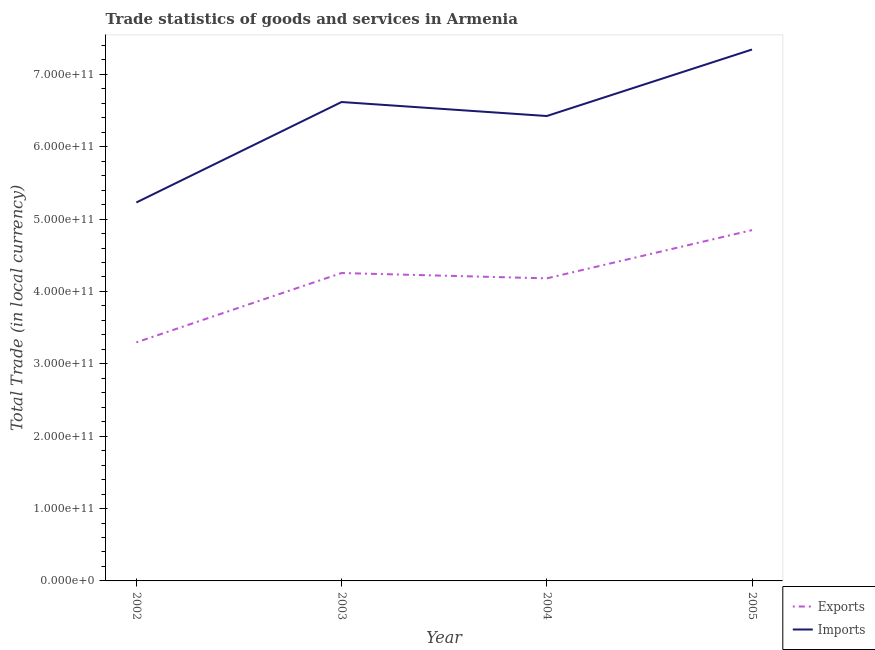Is the number of lines equal to the number of legend labels?
Your answer should be very brief. Yes. What is the export of goods and services in 2003?
Your answer should be very brief. 4.25e+11. Across all years, what is the maximum imports of goods and services?
Give a very brief answer. 7.34e+11. Across all years, what is the minimum export of goods and services?
Offer a very short reply. 3.30e+11. In which year was the imports of goods and services maximum?
Give a very brief answer. 2005. What is the total export of goods and services in the graph?
Make the answer very short. 1.66e+12. What is the difference between the imports of goods and services in 2003 and that in 2005?
Offer a very short reply. -7.26e+1. What is the difference between the export of goods and services in 2005 and the imports of goods and services in 2004?
Ensure brevity in your answer.  -1.58e+11. What is the average imports of goods and services per year?
Offer a very short reply. 6.40e+11. In the year 2003, what is the difference between the imports of goods and services and export of goods and services?
Offer a terse response. 2.36e+11. What is the ratio of the export of goods and services in 2002 to that in 2004?
Make the answer very short. 0.79. Is the export of goods and services in 2003 less than that in 2005?
Your answer should be compact. Yes. What is the difference between the highest and the second highest export of goods and services?
Offer a very short reply. 5.93e+1. What is the difference between the highest and the lowest imports of goods and services?
Ensure brevity in your answer.  2.11e+11. Is the imports of goods and services strictly less than the export of goods and services over the years?
Ensure brevity in your answer.  No. How many years are there in the graph?
Provide a short and direct response. 4. What is the difference between two consecutive major ticks on the Y-axis?
Give a very brief answer. 1.00e+11. Where does the legend appear in the graph?
Offer a very short reply. Bottom right. How many legend labels are there?
Make the answer very short. 2. What is the title of the graph?
Offer a very short reply. Trade statistics of goods and services in Armenia. What is the label or title of the Y-axis?
Provide a short and direct response. Total Trade (in local currency). What is the Total Trade (in local currency) of Exports in 2002?
Provide a short and direct response. 3.30e+11. What is the Total Trade (in local currency) in Imports in 2002?
Provide a short and direct response. 5.23e+11. What is the Total Trade (in local currency) of Exports in 2003?
Your answer should be compact. 4.25e+11. What is the Total Trade (in local currency) in Imports in 2003?
Provide a short and direct response. 6.62e+11. What is the Total Trade (in local currency) of Exports in 2004?
Make the answer very short. 4.18e+11. What is the Total Trade (in local currency) of Imports in 2004?
Your answer should be very brief. 6.42e+11. What is the Total Trade (in local currency) of Exports in 2005?
Make the answer very short. 4.85e+11. What is the Total Trade (in local currency) of Imports in 2005?
Keep it short and to the point. 7.34e+11. Across all years, what is the maximum Total Trade (in local currency) of Exports?
Offer a terse response. 4.85e+11. Across all years, what is the maximum Total Trade (in local currency) in Imports?
Offer a terse response. 7.34e+11. Across all years, what is the minimum Total Trade (in local currency) of Exports?
Ensure brevity in your answer.  3.30e+11. Across all years, what is the minimum Total Trade (in local currency) of Imports?
Keep it short and to the point. 5.23e+11. What is the total Total Trade (in local currency) of Exports in the graph?
Your answer should be very brief. 1.66e+12. What is the total Total Trade (in local currency) of Imports in the graph?
Provide a short and direct response. 2.56e+12. What is the difference between the Total Trade (in local currency) in Exports in 2002 and that in 2003?
Your response must be concise. -9.58e+1. What is the difference between the Total Trade (in local currency) of Imports in 2002 and that in 2003?
Your answer should be very brief. -1.39e+11. What is the difference between the Total Trade (in local currency) in Exports in 2002 and that in 2004?
Your response must be concise. -8.85e+1. What is the difference between the Total Trade (in local currency) in Imports in 2002 and that in 2004?
Your answer should be very brief. -1.19e+11. What is the difference between the Total Trade (in local currency) of Exports in 2002 and that in 2005?
Give a very brief answer. -1.55e+11. What is the difference between the Total Trade (in local currency) of Imports in 2002 and that in 2005?
Your response must be concise. -2.11e+11. What is the difference between the Total Trade (in local currency) of Exports in 2003 and that in 2004?
Your response must be concise. 7.36e+09. What is the difference between the Total Trade (in local currency) of Imports in 2003 and that in 2004?
Your answer should be compact. 1.93e+1. What is the difference between the Total Trade (in local currency) of Exports in 2003 and that in 2005?
Ensure brevity in your answer.  -5.93e+1. What is the difference between the Total Trade (in local currency) in Imports in 2003 and that in 2005?
Provide a short and direct response. -7.26e+1. What is the difference between the Total Trade (in local currency) in Exports in 2004 and that in 2005?
Your answer should be very brief. -6.66e+1. What is the difference between the Total Trade (in local currency) of Imports in 2004 and that in 2005?
Your response must be concise. -9.19e+1. What is the difference between the Total Trade (in local currency) in Exports in 2002 and the Total Trade (in local currency) in Imports in 2003?
Make the answer very short. -3.32e+11. What is the difference between the Total Trade (in local currency) in Exports in 2002 and the Total Trade (in local currency) in Imports in 2004?
Provide a succinct answer. -3.13e+11. What is the difference between the Total Trade (in local currency) in Exports in 2002 and the Total Trade (in local currency) in Imports in 2005?
Provide a short and direct response. -4.05e+11. What is the difference between the Total Trade (in local currency) in Exports in 2003 and the Total Trade (in local currency) in Imports in 2004?
Give a very brief answer. -2.17e+11. What is the difference between the Total Trade (in local currency) of Exports in 2003 and the Total Trade (in local currency) of Imports in 2005?
Your answer should be compact. -3.09e+11. What is the difference between the Total Trade (in local currency) of Exports in 2004 and the Total Trade (in local currency) of Imports in 2005?
Your answer should be compact. -3.16e+11. What is the average Total Trade (in local currency) of Exports per year?
Give a very brief answer. 4.14e+11. What is the average Total Trade (in local currency) of Imports per year?
Your response must be concise. 6.40e+11. In the year 2002, what is the difference between the Total Trade (in local currency) in Exports and Total Trade (in local currency) in Imports?
Your response must be concise. -1.93e+11. In the year 2003, what is the difference between the Total Trade (in local currency) in Exports and Total Trade (in local currency) in Imports?
Offer a terse response. -2.36e+11. In the year 2004, what is the difference between the Total Trade (in local currency) of Exports and Total Trade (in local currency) of Imports?
Ensure brevity in your answer.  -2.24e+11. In the year 2005, what is the difference between the Total Trade (in local currency) in Exports and Total Trade (in local currency) in Imports?
Ensure brevity in your answer.  -2.50e+11. What is the ratio of the Total Trade (in local currency) in Exports in 2002 to that in 2003?
Your answer should be compact. 0.77. What is the ratio of the Total Trade (in local currency) in Imports in 2002 to that in 2003?
Your answer should be very brief. 0.79. What is the ratio of the Total Trade (in local currency) in Exports in 2002 to that in 2004?
Offer a terse response. 0.79. What is the ratio of the Total Trade (in local currency) of Imports in 2002 to that in 2004?
Offer a terse response. 0.81. What is the ratio of the Total Trade (in local currency) of Exports in 2002 to that in 2005?
Keep it short and to the point. 0.68. What is the ratio of the Total Trade (in local currency) in Imports in 2002 to that in 2005?
Make the answer very short. 0.71. What is the ratio of the Total Trade (in local currency) in Exports in 2003 to that in 2004?
Keep it short and to the point. 1.02. What is the ratio of the Total Trade (in local currency) of Imports in 2003 to that in 2004?
Keep it short and to the point. 1.03. What is the ratio of the Total Trade (in local currency) of Exports in 2003 to that in 2005?
Keep it short and to the point. 0.88. What is the ratio of the Total Trade (in local currency) in Imports in 2003 to that in 2005?
Offer a terse response. 0.9. What is the ratio of the Total Trade (in local currency) of Exports in 2004 to that in 2005?
Make the answer very short. 0.86. What is the ratio of the Total Trade (in local currency) in Imports in 2004 to that in 2005?
Ensure brevity in your answer.  0.87. What is the difference between the highest and the second highest Total Trade (in local currency) of Exports?
Ensure brevity in your answer.  5.93e+1. What is the difference between the highest and the second highest Total Trade (in local currency) in Imports?
Your response must be concise. 7.26e+1. What is the difference between the highest and the lowest Total Trade (in local currency) in Exports?
Give a very brief answer. 1.55e+11. What is the difference between the highest and the lowest Total Trade (in local currency) in Imports?
Provide a succinct answer. 2.11e+11. 